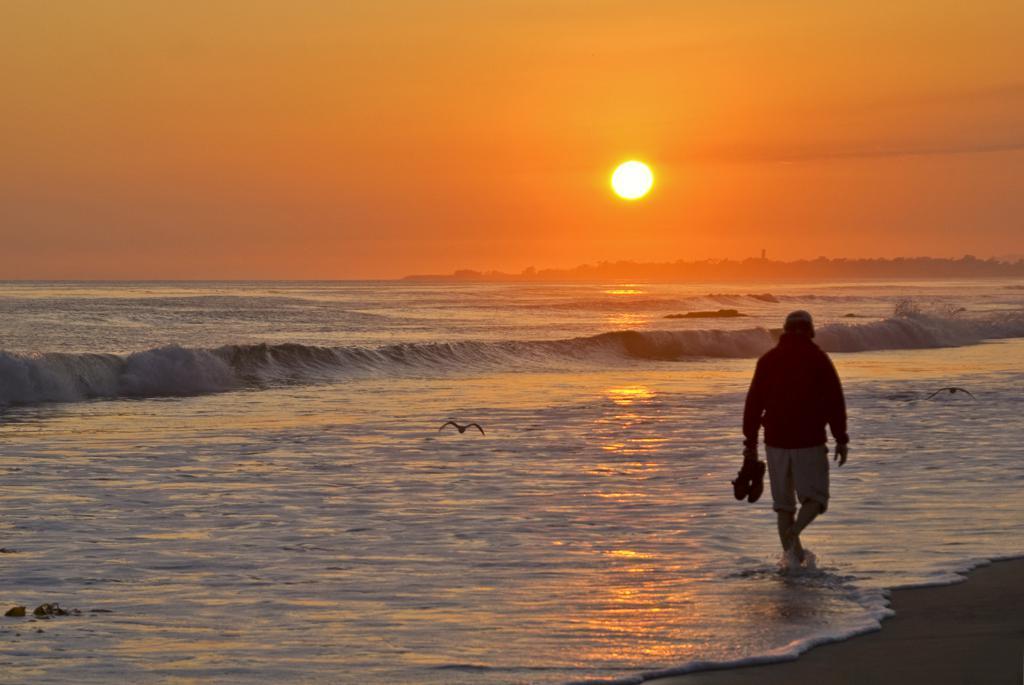Can you describe this image briefly? In this image there is a person walking in the water and he is holding shoes. There are birds. In the background of the image there are trees, mountains, sun and sky. 